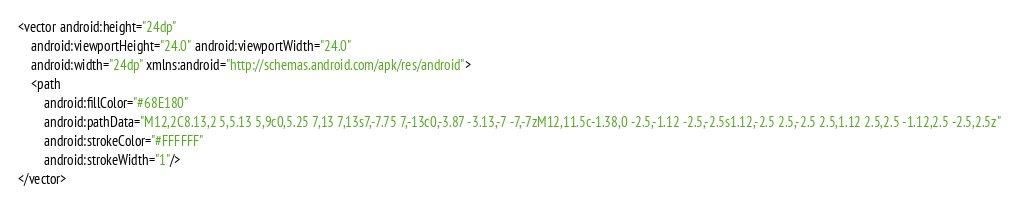<code> <loc_0><loc_0><loc_500><loc_500><_XML_><vector android:height="24dp"
    android:viewportHeight="24.0" android:viewportWidth="24.0"
    android:width="24dp" xmlns:android="http://schemas.android.com/apk/res/android">
    <path
        android:fillColor="#68E180"
        android:pathData="M12,2C8.13,2 5,5.13 5,9c0,5.25 7,13 7,13s7,-7.75 7,-13c0,-3.87 -3.13,-7 -7,-7zM12,11.5c-1.38,0 -2.5,-1.12 -2.5,-2.5s1.12,-2.5 2.5,-2.5 2.5,1.12 2.5,2.5 -1.12,2.5 -2.5,2.5z"
        android:strokeColor="#FFFFFF"
        android:strokeWidth="1"/>
</vector>
</code> 